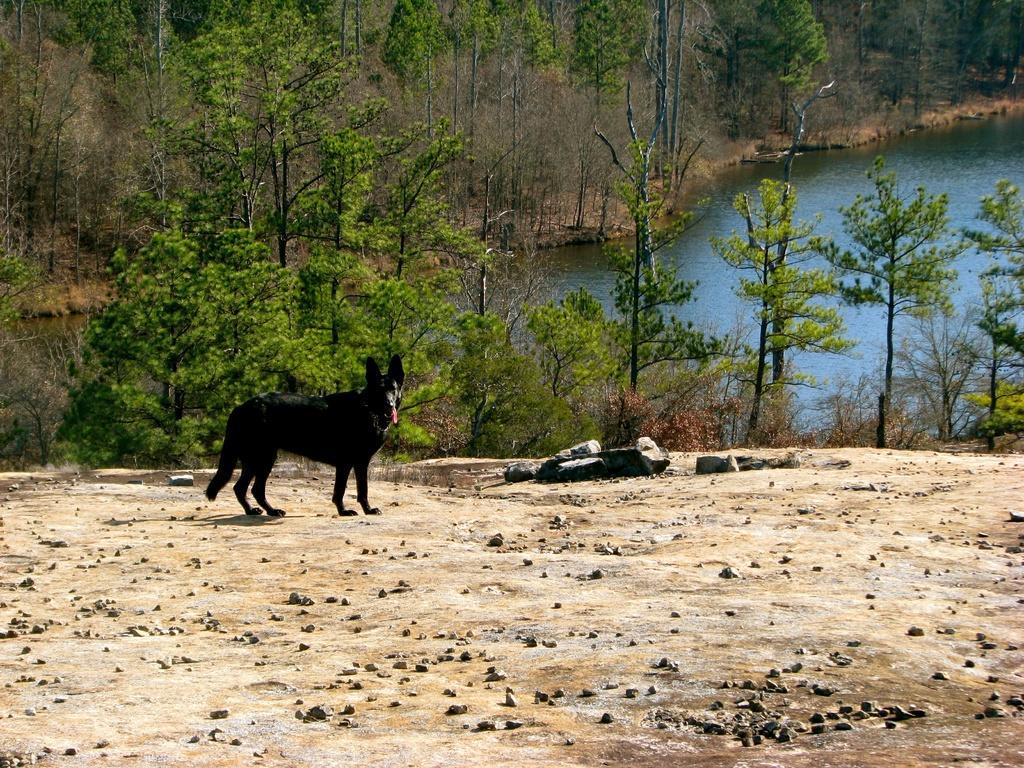How would you summarize this image in a sentence or two? This image consists of a dog in black color. At the bottom, there are stones on the ground. In the background, we can see many trees. In the middle, there is water. 